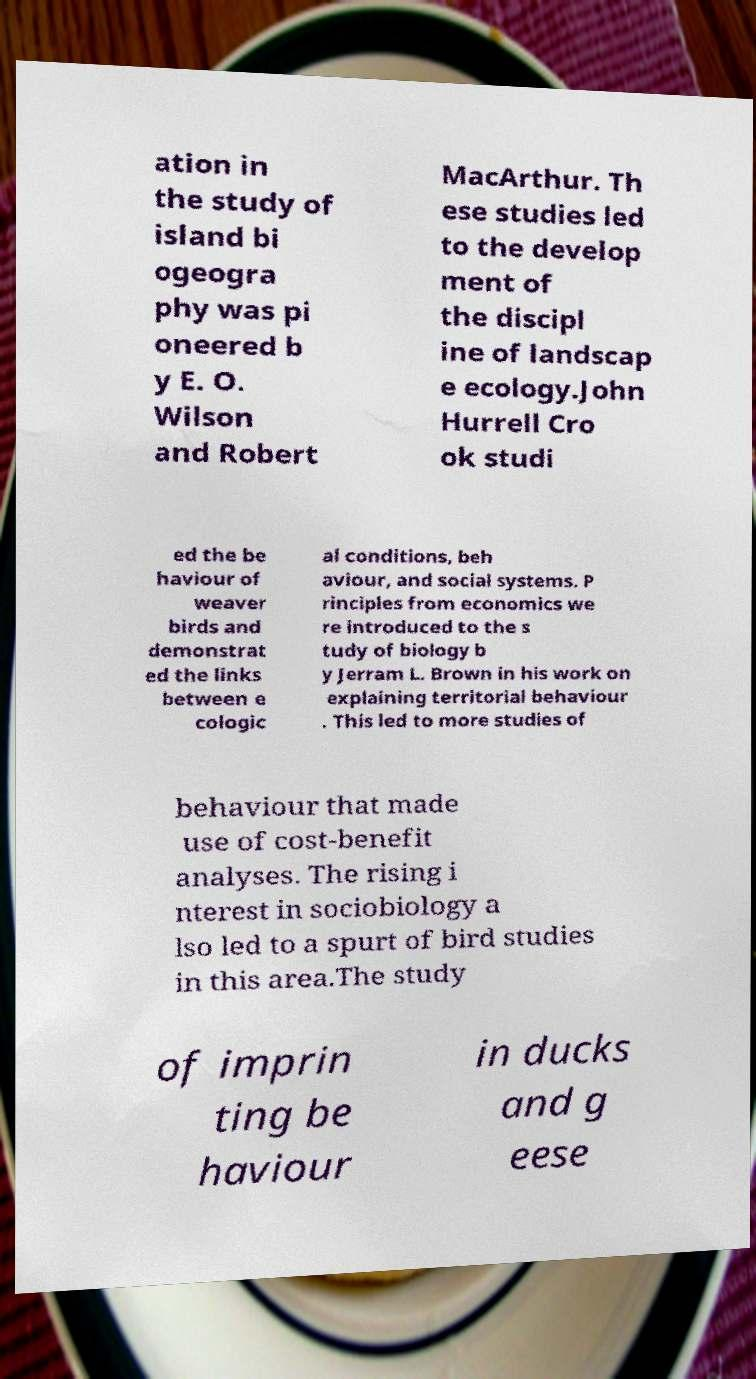There's text embedded in this image that I need extracted. Can you transcribe it verbatim? ation in the study of island bi ogeogra phy was pi oneered b y E. O. Wilson and Robert MacArthur. Th ese studies led to the develop ment of the discipl ine of landscap e ecology.John Hurrell Cro ok studi ed the be haviour of weaver birds and demonstrat ed the links between e cologic al conditions, beh aviour, and social systems. P rinciples from economics we re introduced to the s tudy of biology b y Jerram L. Brown in his work on explaining territorial behaviour . This led to more studies of behaviour that made use of cost-benefit analyses. The rising i nterest in sociobiology a lso led to a spurt of bird studies in this area.The study of imprin ting be haviour in ducks and g eese 